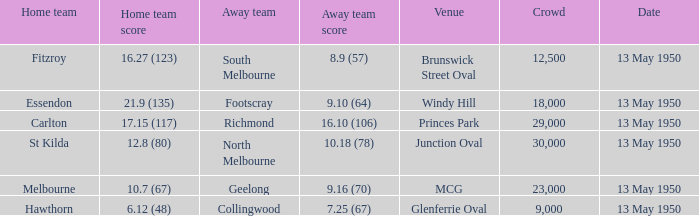What was the lowest crowd size at the Windy Hill venue? 18000.0. 